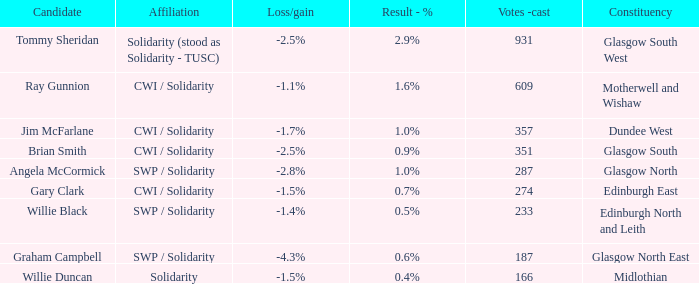What was the loss/gain when the affiliation was solidarity? -1.5%. 